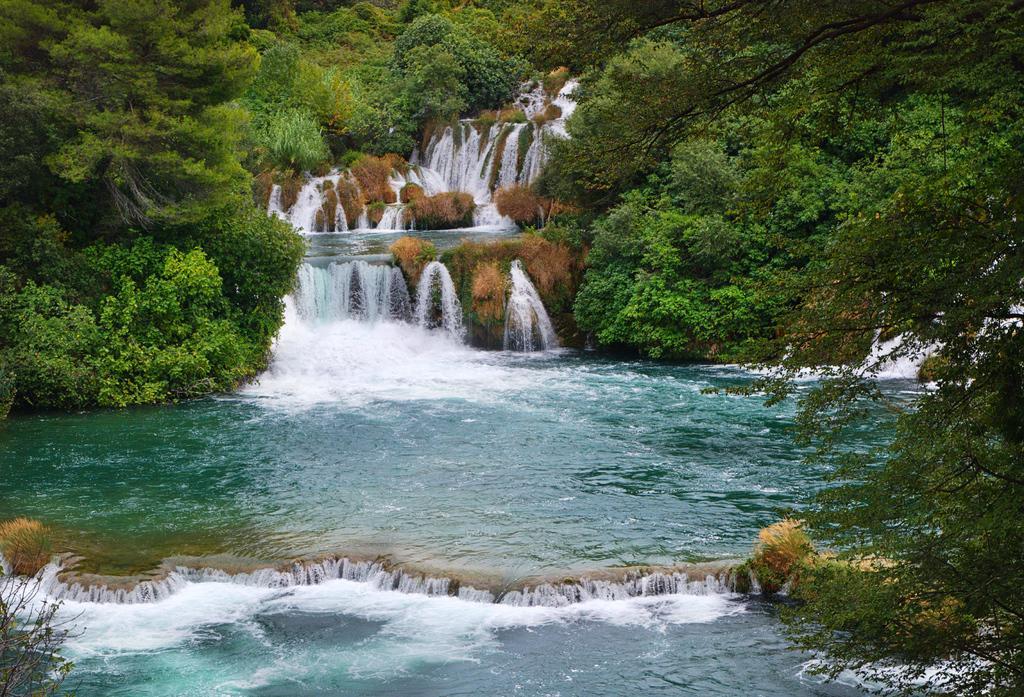In one or two sentences, can you explain what this image depicts? In this image we can see a waterfall and we can also see trees in the background. 